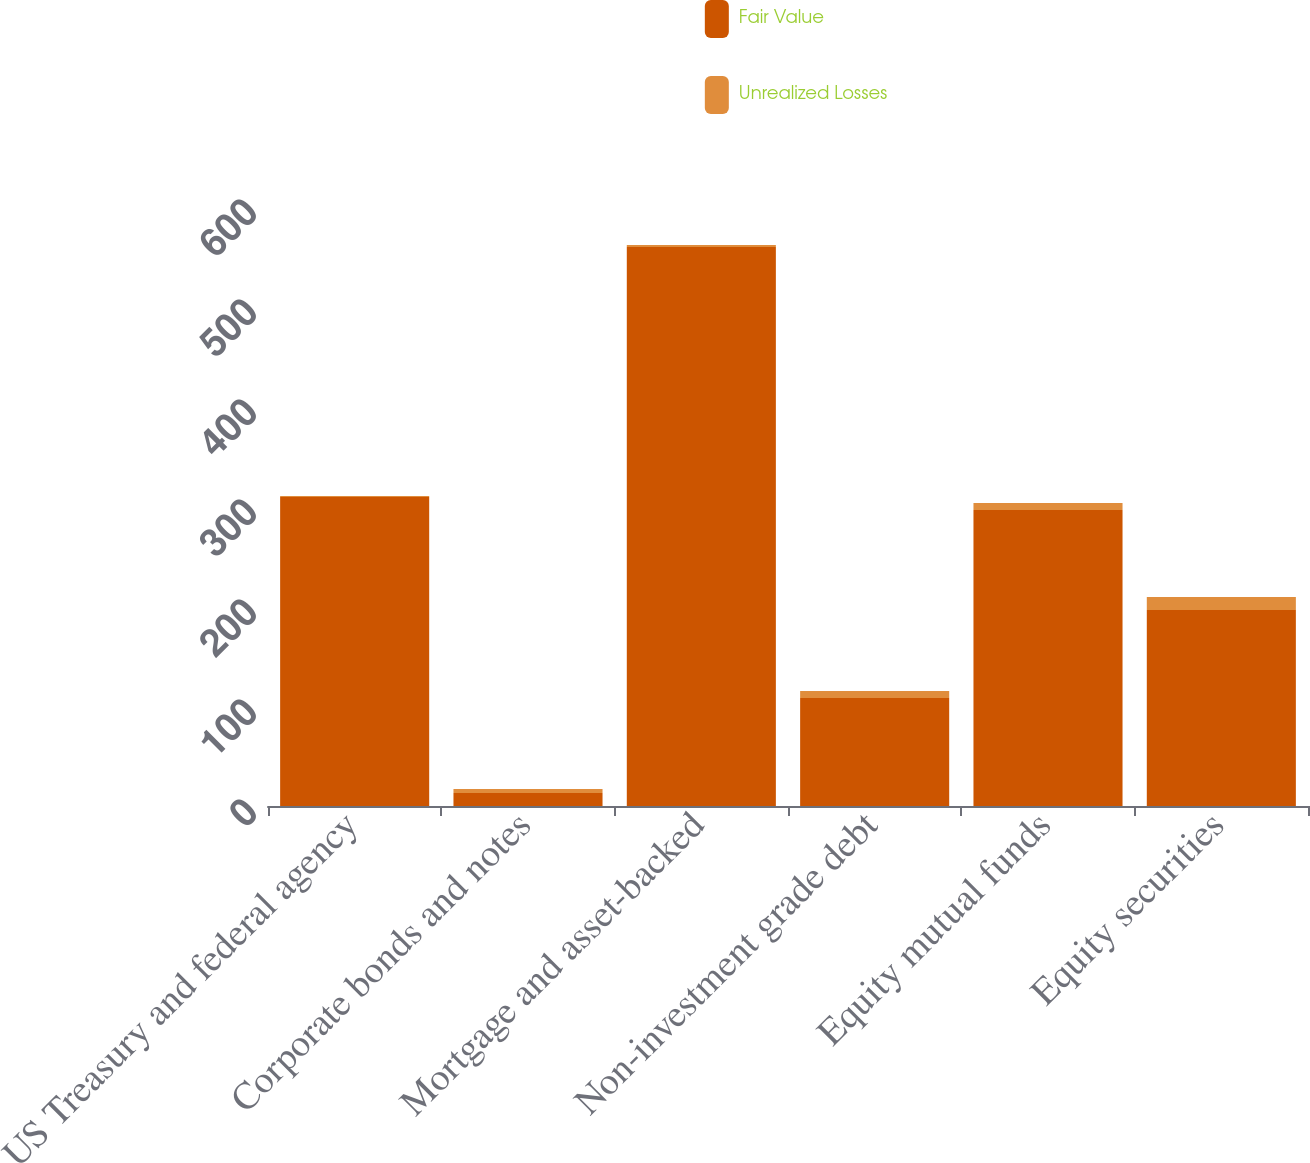<chart> <loc_0><loc_0><loc_500><loc_500><stacked_bar_chart><ecel><fcel>US Treasury and federal agency<fcel>Corporate bonds and notes<fcel>Mortgage and asset-backed<fcel>Non-investment grade debt<fcel>Equity mutual funds<fcel>Equity securities<nl><fcel>Fair Value<fcel>309<fcel>13<fcel>559<fcel>108<fcel>296<fcel>196<nl><fcel>Unrealized Losses<fcel>1<fcel>4<fcel>2<fcel>7<fcel>7<fcel>13<nl></chart> 